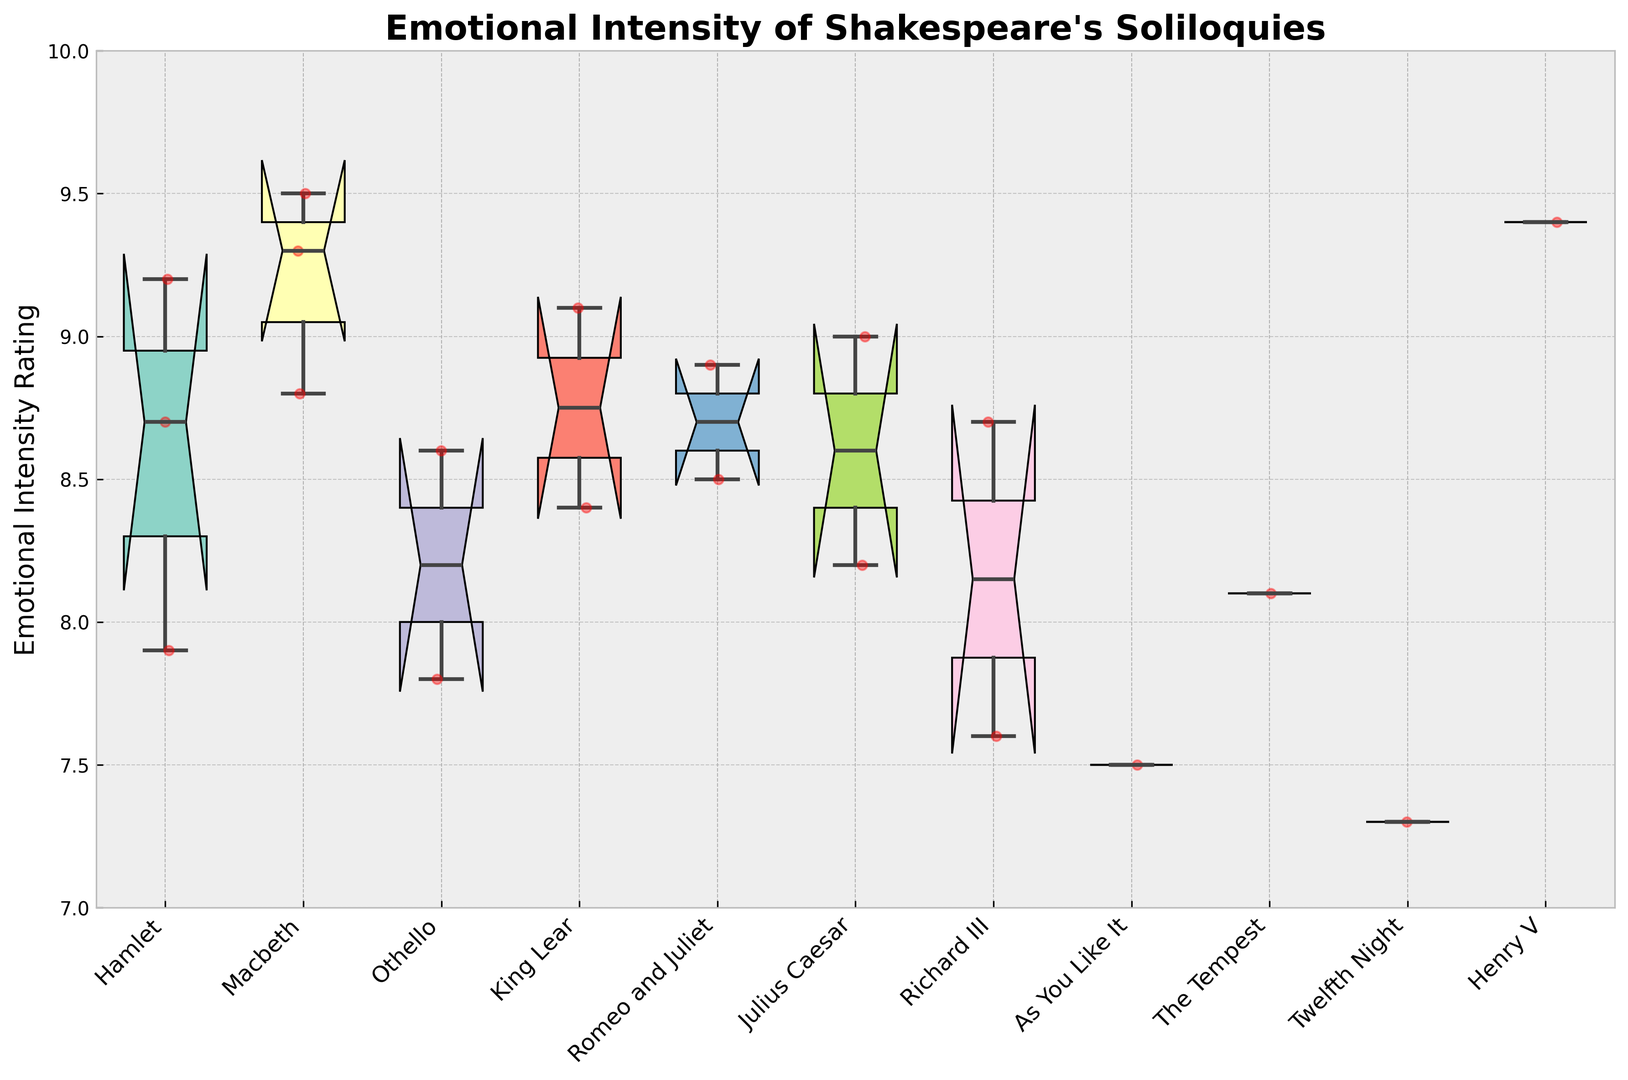Which play has the highest median emotional intensity rating? To find the play with the highest median emotional intensity rating, refer to the middle line inside each box in the box plot. The play with the lowest middle line among all boxes has the highest median value.
Answer: Henry V Which play has the lowest median emotional intensity rating? To determine the play with the lowest median emotional intensity rating, look for the box plot with the lowest middle line.
Answer: Twelfth Night What is the difference in median intensity ratings between the highest and lowest rated plays? First, identify the highest and lowest median values from the box plots. Henry V has the highest median at approximately 9.4, and Twelfth Night has the lowest median at approximately 7.3. Subtract the two values: 9.4 - 7.3 = 2.1.
Answer: 2.1 Which play has the widest range of emotional intensity ratings? The range of emotional intensity is represented by the height of each box, including whiskers. The play with the widest box plot span from the bottom whisker to the top whisker has the widest range.
Answer: Othello Which soliloquies have intensity ratings above 9? Identify the individual red dots representing soliloquies on the left y-axis above the value of 9. These soliloquies appear within plays such as Hamlet, Macbeth, Julius Caesar, Henry V.
Answer: To be or not to be (Hamlet), Is this a dagger which I see before me (Macbeth), Tomorrow and tomorrow and tomorrow (Macbeth), Friends Romans countrymen (Julius Caesar), Once more unto the breach (Henry V) Which play's box plot has a color closest to orange? Observing the color of each box plot, match the color that is visually closest to orange.
Answer: As You Like It How does the median intensity rating for "Romeo and Juliet" compare with that of "King Lear"? Compare the middle lines of the boxes for "Romeo and Juliet" and "King Lear." Romeo and Juliet has a slightly higher median value.
Answer: Romeo and Juliet is higher Between "Richard III" and "Henry V," which play has a higher maximum intensity rating, and what are those values? Identify the top whisker of each box plot for these two plays, which represent the maximum intensity ratings. Henry V's top whisker is around 9.4, while Richard III is around 8.7.
Answer: Henry V, 9.4; Richard III, 8.7 Which play has the most consistent emotional intensity ratings, indicated by the smallest interquartile range (IQR)? The IQR is represented by the height of the central box (excluding whiskers). Look for the plot with the shortest box height.
Answer: Twelfth Night 